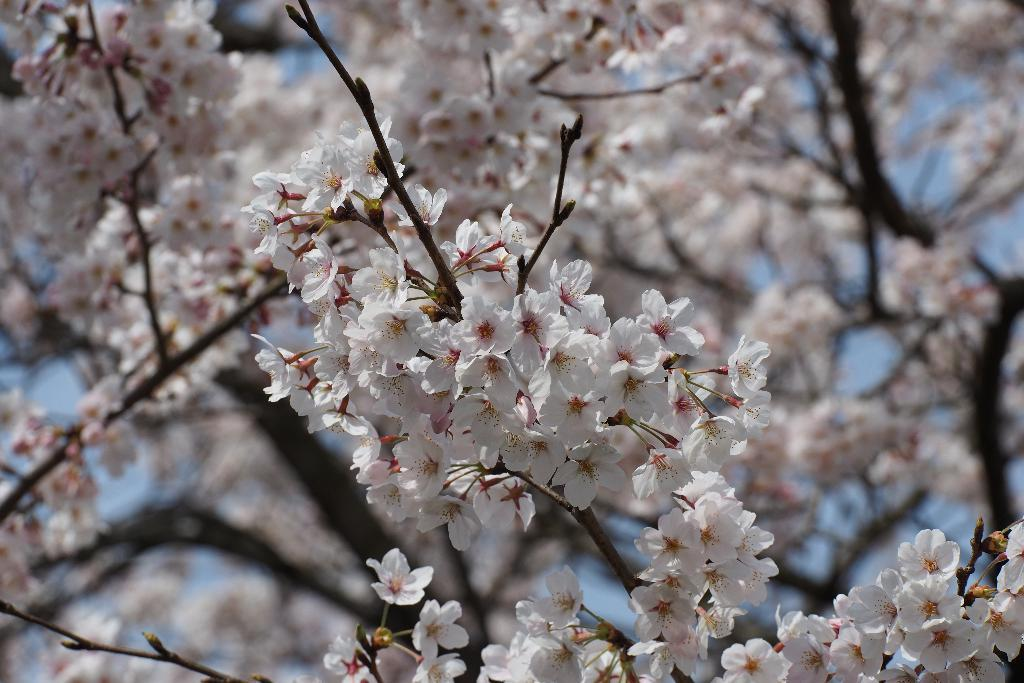What is present in the image? There is a tree in the image. What can be observed about the tree? The tree has white flowers. What is visible in the background of the image? The sky is visible in the background of the image. What type of wheel can be seen attached to the tree in the image? There is no wheel present or attached to the tree in the image. What kind of creature can be seen interacting with the tree in the image? There are no creatures present or interacting with the tree in the image. 